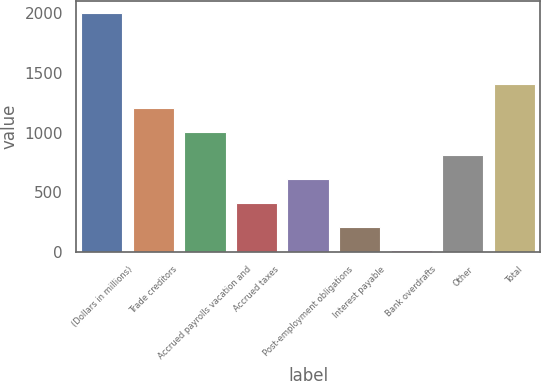Convert chart to OTSL. <chart><loc_0><loc_0><loc_500><loc_500><bar_chart><fcel>(Dollars in millions)<fcel>Trade creditors<fcel>Accrued payrolls vacation and<fcel>Accrued taxes<fcel>Post-employment obligations<fcel>Interest payable<fcel>Bank overdrafts<fcel>Other<fcel>Total<nl><fcel>2005<fcel>1207<fcel>1007.5<fcel>409<fcel>608.5<fcel>209.5<fcel>10<fcel>808<fcel>1406.5<nl></chart> 